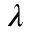Convert formula to latex. <formula><loc_0><loc_0><loc_500><loc_500>\lambda</formula> 